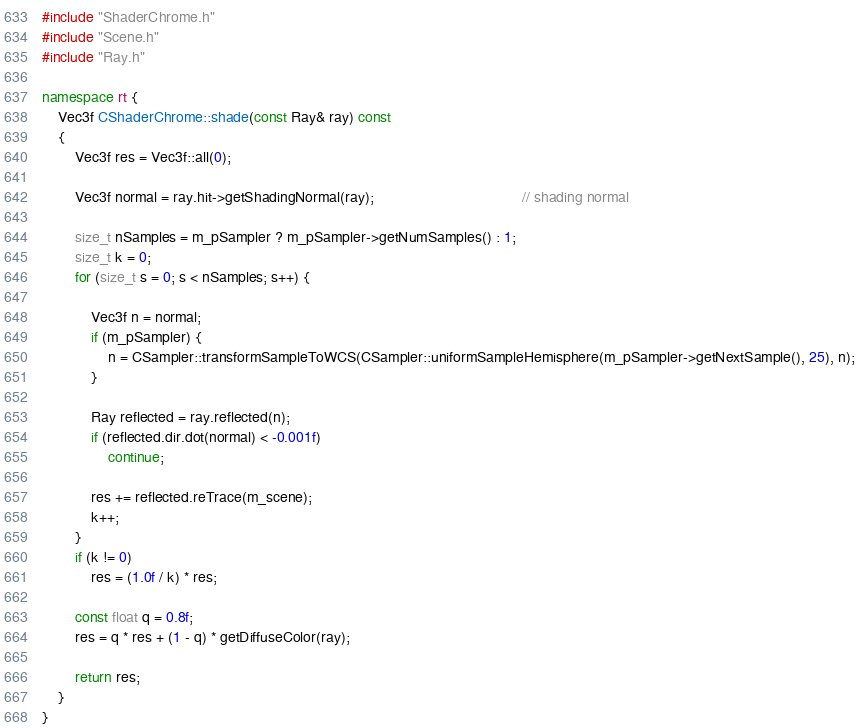Convert code to text. <code><loc_0><loc_0><loc_500><loc_500><_C++_>#include "ShaderChrome.h"
#include "Scene.h"
#include "Ray.h"

namespace rt {
	Vec3f CShaderChrome::shade(const Ray& ray) const 
	{
		Vec3f res = Vec3f::all(0);

		Vec3f normal = ray.hit->getShadingNormal(ray);									// shading normal

		size_t nSamples = m_pSampler ? m_pSampler->getNumSamples() : 1;
		size_t k = 0;
		for (size_t s = 0; s < nSamples; s++) {

			Vec3f n = normal;
			if (m_pSampler) {
				n = CSampler::transformSampleToWCS(CSampler::uniformSampleHemisphere(m_pSampler->getNextSample(), 25), n);
			}

			Ray reflected = ray.reflected(n);
			if (reflected.dir.dot(normal) < -0.001f) 
				continue;

			res += reflected.reTrace(m_scene);
			k++;
		}
		if (k != 0)
			res = (1.0f / k) * res;
		
		const float q = 0.8f;
		res = q * res + (1 - q) * getDiffuseColor(ray);
		
		return res;
	}
}
</code> 